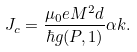Convert formula to latex. <formula><loc_0><loc_0><loc_500><loc_500>J _ { c } = \frac { \mu _ { 0 } e M ^ { 2 } d } { \hbar { g } ( P , 1 ) } \alpha k .</formula> 